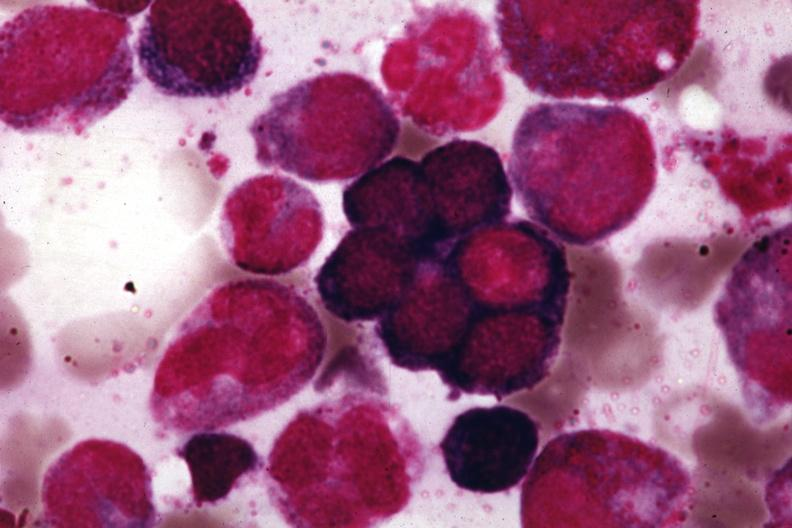does this image show wrights?
Answer the question using a single word or phrase. Yes 